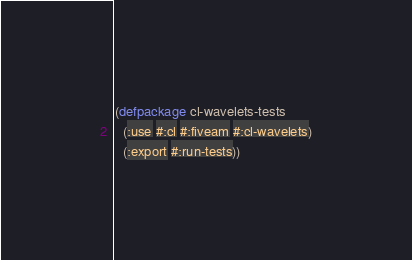<code> <loc_0><loc_0><loc_500><loc_500><_Lisp_>(defpackage cl-wavelets-tests
  (:use #:cl #:fiveam #:cl-wavelets)
  (:export #:run-tests))
</code> 